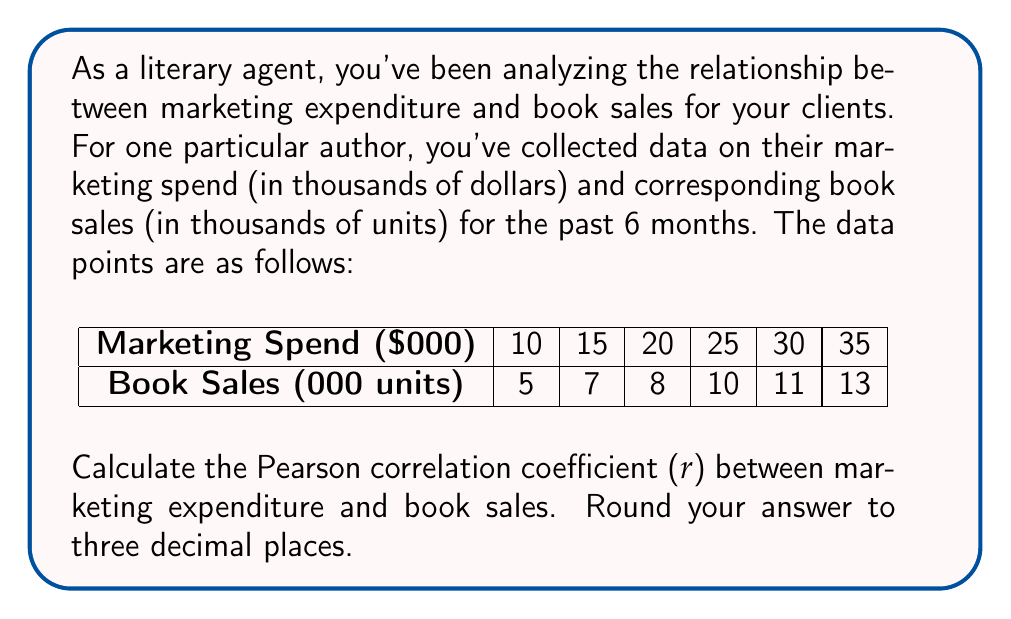Could you help me with this problem? To calculate the Pearson correlation coefficient (r), we'll use the formula:

$$ r = \frac{n\sum xy - \sum x \sum y}{\sqrt{[n\sum x^2 - (\sum x)^2][n\sum y^2 - (\sum y)^2]}} $$

Where:
$n$ = number of data points
$x$ = marketing spend
$y$ = book sales

Step 1: Calculate the required sums:
$n = 6$
$\sum x = 10 + 15 + 20 + 25 + 30 + 35 = 135$
$\sum y = 5 + 7 + 8 + 10 + 11 + 13 = 54$
$\sum xy = (10)(5) + (15)(7) + (20)(8) + (25)(10) + (30)(11) + (35)(13) = 1,630$
$\sum x^2 = 10^2 + 15^2 + 20^2 + 25^2 + 30^2 + 35^2 = 3,775$
$\sum y^2 = 5^2 + 7^2 + 8^2 + 10^2 + 11^2 + 13^2 = 524$

Step 2: Apply the formula:

$$ r = \frac{6(1,630) - (135)(54)}{\sqrt{[6(3,775) - 135^2][6(524) - 54^2]}} $$

$$ r = \frac{9,780 - 7,290}{\sqrt{(22,650 - 18,225)(3,144 - 2,916)}} $$

$$ r = \frac{2,490}{\sqrt{(4,425)(228)}} $$

$$ r = \frac{2,490}{\sqrt{1,008,900}} $$

$$ r = \frac{2,490}{1,004.44} $$

$$ r \approx 0.9954 $$

Rounding to three decimal places, we get 0.995.
Answer: 0.995 